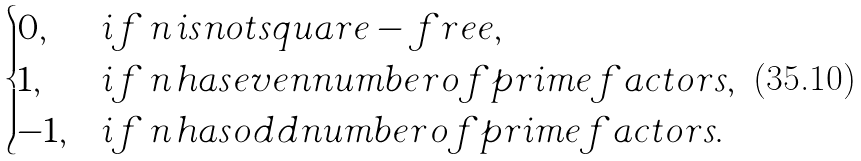<formula> <loc_0><loc_0><loc_500><loc_500>\begin{cases} 0 , & { i f } \, n \, { i s n o t s q u a r e - f r e e , } \\ 1 , & { i f } \, n \, { h a s e v e n n u m b e r o f p r i m e f a c t o r s , } \\ - 1 , & { i f } \, n \, { h a s o d d n u m b e r o f p r i m e f a c t o r s . } \end{cases}</formula> 